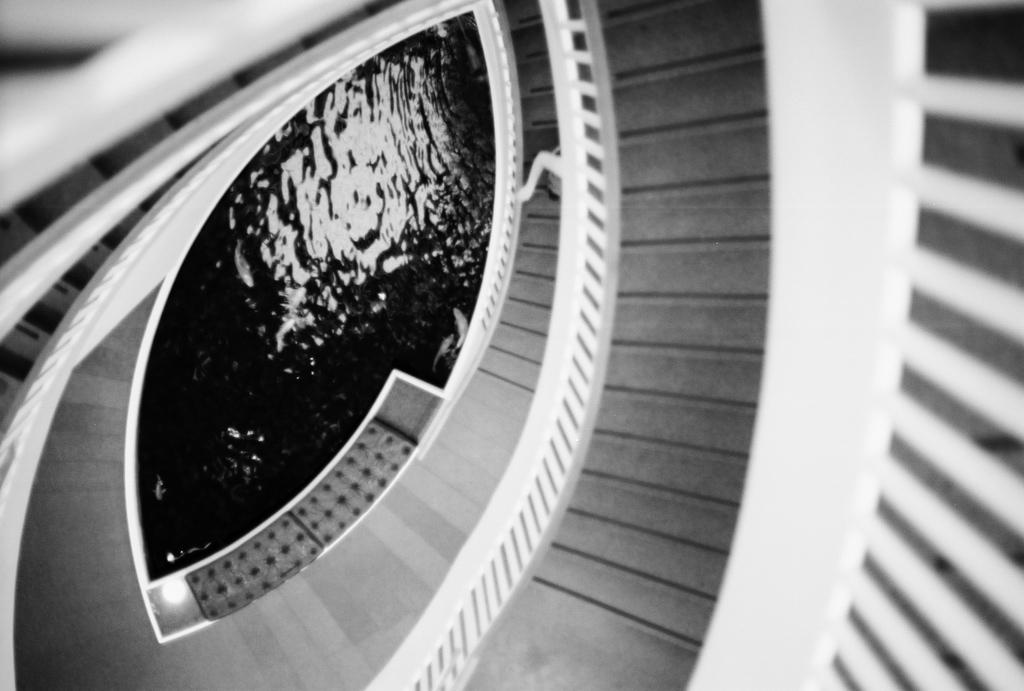What is the color scheme of the image? The image is black and white. What can be seen in the image besides the color scheme? There are stairs and a swimming pool under the stairs in the image. How was the image captured? The image is captured from the top. What sense is being used to experience the swimming pool in the image? The image is a visual representation, so the sense being used to experience the swimming pool is sight. However, the swimming pool cannot be experienced through the image itself, as it is not a real swimming pool. 